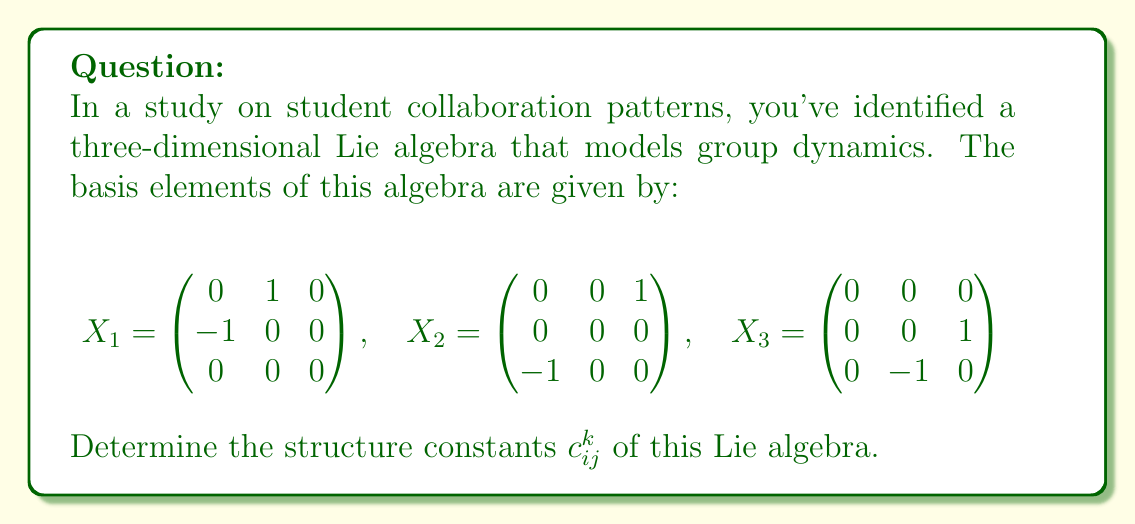Give your solution to this math problem. To find the structure constants $c_{ij}^k$ of a Lie algebra, we need to compute the Lie brackets $[X_i, X_j]$ for all pairs of basis elements and express the results as linear combinations of the basis elements.

The Lie bracket of two matrices $A$ and $B$ is defined as $[A,B] = AB - BA$.

1) First, let's compute $[X_1, X_2]$:

   $$[X_1, X_2] = X_1X_2 - X_2X_1 = \begin{pmatrix} 0 & 0 & 0 \\ 0 & 0 & -1 \\ 0 & 1 & 0 \end{pmatrix} = X_3$$

2) Next, $[X_1, X_3]$:

   $$[X_1, X_3] = X_1X_3 - X_3X_1 = \begin{pmatrix} 0 & 0 & -1 \\ 0 & 0 & 0 \\ 1 & 0 & 0 \end{pmatrix} = -X_2$$

3) Finally, $[X_2, X_3]$:

   $$[X_2, X_3] = X_2X_3 - X_3X_2 = \begin{pmatrix} 1 & 0 & 0 \\ 0 & -1 & 0 \\ 0 & 0 & 0 \end{pmatrix} = X_1$$

Now, we can express these results in terms of the structure constants:

$$[X_1, X_2] = c_{12}^1 X_1 + c_{12}^2 X_2 + c_{12}^3 X_3 = X_3$$
$$[X_1, X_3] = c_{13}^1 X_1 + c_{13}^2 X_2 + c_{13}^3 X_3 = -X_2$$
$$[X_2, X_3] = c_{23}^1 X_1 + c_{23}^2 X_2 + c_{23}^3 X_3 = X_1$$

Comparing coefficients, we can identify the non-zero structure constants:

$c_{12}^3 = 1$
$c_{13}^2 = -1$
$c_{23}^1 = 1$

All other structure constants are zero.
Answer: The non-zero structure constants are:
$c_{12}^3 = 1$, $c_{13}^2 = -1$, $c_{23}^1 = 1$
All other $c_{ij}^k = 0$. 